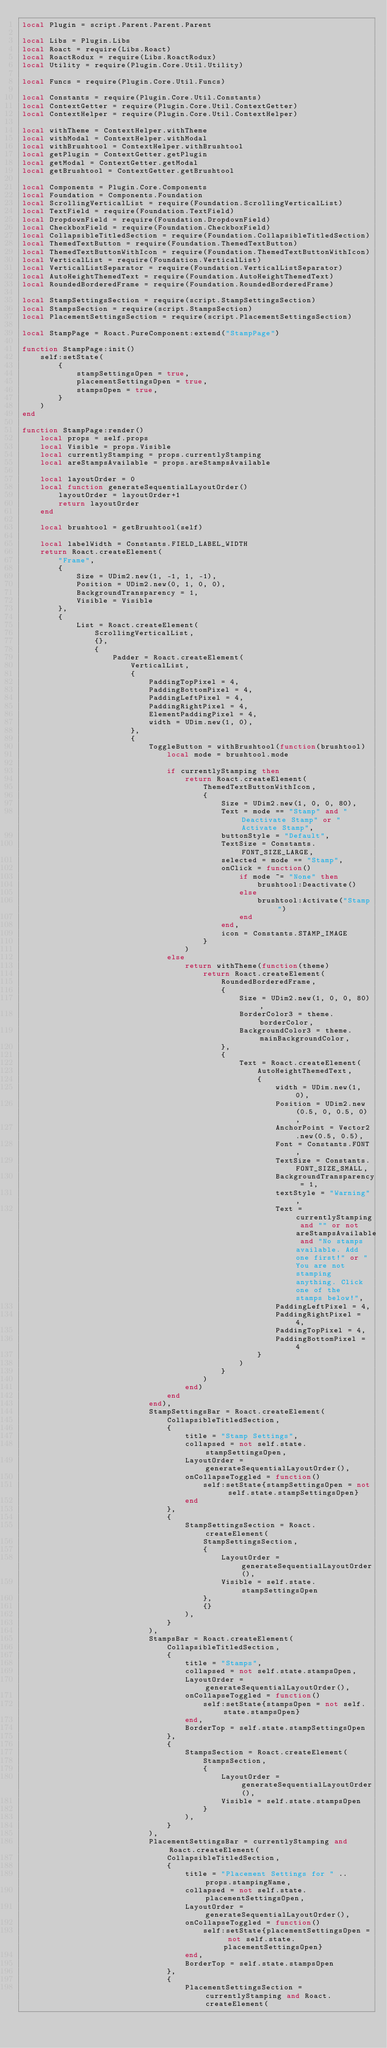Convert code to text. <code><loc_0><loc_0><loc_500><loc_500><_Lua_>local Plugin = script.Parent.Parent.Parent

local Libs = Plugin.Libs
local Roact = require(Libs.Roact)
local RoactRodux = require(Libs.RoactRodux)
local Utility = require(Plugin.Core.Util.Utility)

local Funcs = require(Plugin.Core.Util.Funcs)

local Constants = require(Plugin.Core.Util.Constants)
local ContextGetter = require(Plugin.Core.Util.ContextGetter)
local ContextHelper = require(Plugin.Core.Util.ContextHelper)

local withTheme = ContextHelper.withTheme
local withModal = ContextHelper.withModal
local withBrushtool = ContextHelper.withBrushtool
local getPlugin = ContextGetter.getPlugin
local getModal = ContextGetter.getModal
local getBrushtool = ContextGetter.getBrushtool

local Components = Plugin.Core.Components
local Foundation = Components.Foundation
local ScrollingVerticalList = require(Foundation.ScrollingVerticalList)
local TextField = require(Foundation.TextField)
local DropdownField = require(Foundation.DropdownField)
local CheckboxField = require(Foundation.CheckboxField)
local CollapsibleTitledSection = require(Foundation.CollapsibleTitledSection)
local ThemedTextButton = require(Foundation.ThemedTextButton)
local ThemedTextButtonWithIcon = require(Foundation.ThemedTextButtonWithIcon)
local VerticalList = require(Foundation.VerticalList)
local VerticalListSeparator = require(Foundation.VerticalListSeparator)
local AutoHeightThemedText = require(Foundation.AutoHeightThemedText)
local RoundedBorderedFrame = require(Foundation.RoundedBorderedFrame)

local StampSettingsSection = require(script.StampSettingsSection)
local StampsSection = require(script.StampsSection)
local PlacementSettingsSection = require(script.PlacementSettingsSection)

local StampPage = Roact.PureComponent:extend("StampPage")

function StampPage:init()
	self:setState(
		{
			stampSettingsOpen = true,
			placementSettingsOpen = true,
			stampsOpen = true,
		}
	)
end

function StampPage:render()
	local props = self.props
	local Visible = props.Visible
	local currentlyStamping = props.currentlyStamping
	local areStampsAvailable = props.areStampsAvailable
	
	local layoutOrder = 0
	local function generateSequentialLayoutOrder()
		layoutOrder = layoutOrder+1
		return layoutOrder
	end

	local brushtool = getBrushtool(self)
	
	local labelWidth = Constants.FIELD_LABEL_WIDTH
	return Roact.createElement(
		"Frame",
		{
			Size = UDim2.new(1, -1, 1, -1),
			Position = UDim2.new(0, 1, 0, 0),
			BackgroundTransparency = 1,
			Visible = Visible
		},
		{
			List = Roact.createElement(
				ScrollingVerticalList,
				{},
				{
					Padder = Roact.createElement(
						VerticalList,
						{
							PaddingTopPixel = 4,
							PaddingBottomPixel = 4,
							PaddingLeftPixel = 4,
							PaddingRightPixel = 4,
							ElementPaddingPixel = 4,
							width = UDim.new(1, 0),
						},
						{
							ToggleButton = withBrushtool(function(brushtool)
								local mode = brushtool.mode
								
								if currentlyStamping then
									return Roact.createElement(
										ThemedTextButtonWithIcon,
										{
											Size = UDim2.new(1, 0, 0, 80),
											Text = mode == "Stamp" and "Deactivate Stamp" or "Activate Stamp",
											buttonStyle = "Default",
											TextSize = Constants.FONT_SIZE_LARGE,
											selected = mode == "Stamp",
											onClick = function()
												if mode ~= "None" then
													brushtool:Deactivate()
												else
													brushtool:Activate("Stamp")
												end
											end,
											icon = Constants.STAMP_IMAGE
										}
									)
								else
									return withTheme(function(theme)
										return Roact.createElement(
											RoundedBorderedFrame,
											{
												Size = UDim2.new(1, 0, 0, 80),
												BorderColor3 = theme.borderColor,
												BackgroundColor3 = theme.mainBackgroundColor,
											},
											{
												Text = Roact.createElement(
													AutoHeightThemedText,
													{
														width = UDim.new(1, 0),
														Position = UDim2.new(0.5, 0, 0.5, 0),
														AnchorPoint = Vector2.new(0.5, 0.5),
														Font = Constants.FONT,
														TextSize = Constants.FONT_SIZE_SMALL,
														BackgroundTransparency = 1,
														textStyle = "Warning",
														Text = currentlyStamping and "" or not areStampsAvailable and "No stamps available. Add one first!" or "You are not stamping anything. Click one of the stamps below!",
														PaddingLeftPixel = 4,
														PaddingRightPixel = 4,
														PaddingTopPixel = 4,
														PaddingBottomPixel = 4
													}
												)
											}
										)
									end)
								end
							end),
							StampSettingsBar = Roact.createElement(
								CollapsibleTitledSection,
								{
									title = "Stamp Settings",
									collapsed = not self.state.stampSettingsOpen,
									LayoutOrder = generateSequentialLayoutOrder(),
									onCollapseToggled = function()
										self:setState{stampSettingsOpen = not self.state.stampSettingsOpen}
									end
								},
								{
									StampSettingsSection = Roact.createElement(
										StampSettingsSection,
										{
											LayoutOrder = generateSequentialLayoutOrder(),
											Visible = self.state.stampSettingsOpen
										},
										{}
									),	
								}
							),
							StampsBar = Roact.createElement(
								CollapsibleTitledSection,
								{
									title = "Stamps",
									collapsed = not self.state.stampsOpen,
									LayoutOrder = generateSequentialLayoutOrder(),
									onCollapseToggled = function()
										self:setState{stampsOpen = not self.state.stampsOpen}
									end,
									BorderTop = self.state.stampSettingsOpen
								},
								{
									StampsSection = Roact.createElement(
										StampsSection,
										{
											LayoutOrder = generateSequentialLayoutOrder(),
											Visible = self.state.stampsOpen
										}
									),
								}
							),
							PlacementSettingsBar = currentlyStamping and Roact.createElement(
								CollapsibleTitledSection,
								{
									title = "Placement Settings for " .. props.stampingName,
									collapsed = not self.state.placementSettingsOpen,
									LayoutOrder = generateSequentialLayoutOrder(),
									onCollapseToggled = function()
										self:setState{placementSettingsOpen = not self.state.placementSettingsOpen}
									end,
									BorderTop = self.state.stampsOpen
								},
								{
									PlacementSettingsSection = currentlyStamping and Roact.createElement(</code> 